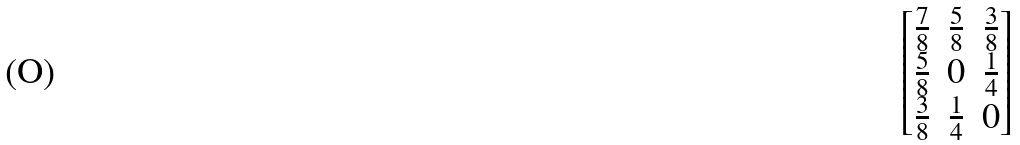<formula> <loc_0><loc_0><loc_500><loc_500>\begin{bmatrix} \frac { 7 } { 8 } & \frac { 5 } { 8 } & \frac { 3 } { 8 } \\ \frac { 5 } { 8 } & 0 & \frac { 1 } { 4 } \\ \frac { 3 } { 8 } & \frac { 1 } { 4 } & 0 \end{bmatrix}</formula> 